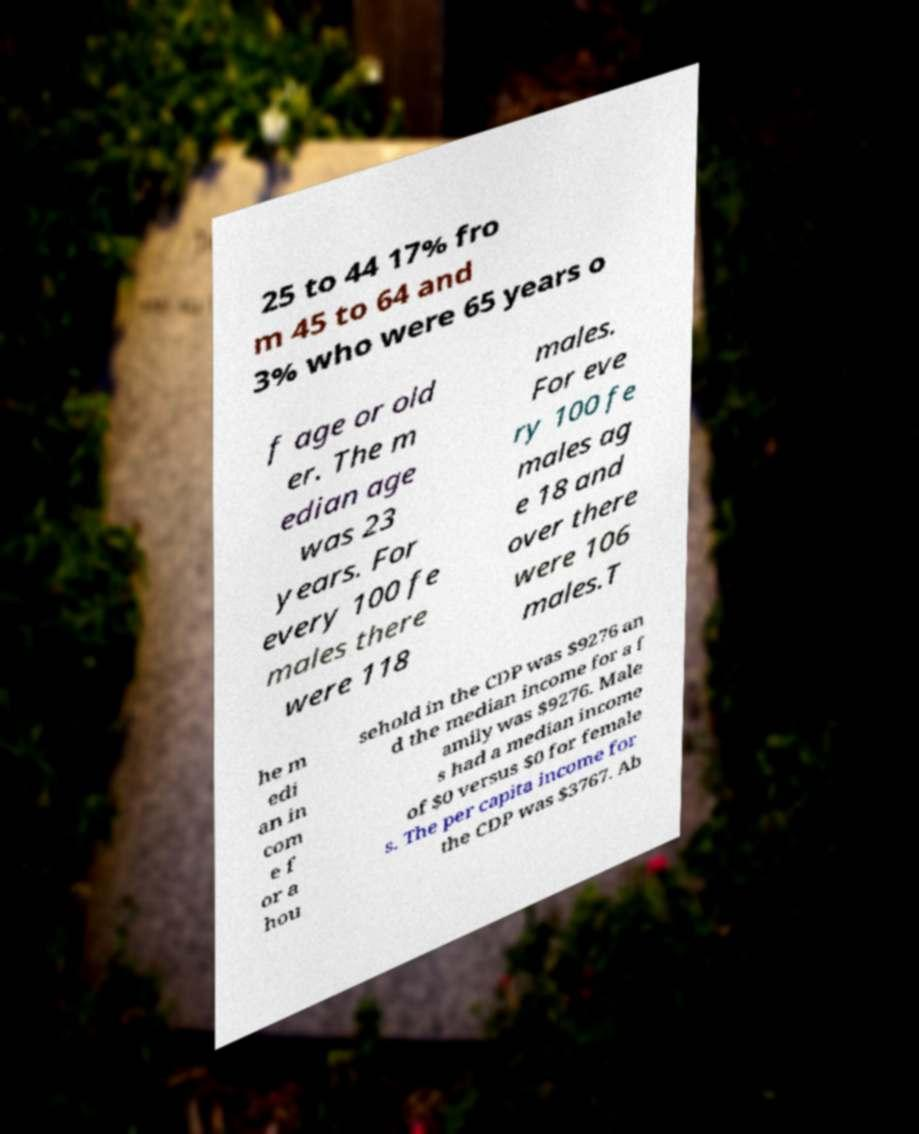What messages or text are displayed in this image? I need them in a readable, typed format. 25 to 44 17% fro m 45 to 64 and 3% who were 65 years o f age or old er. The m edian age was 23 years. For every 100 fe males there were 118 males. For eve ry 100 fe males ag e 18 and over there were 106 males.T he m edi an in com e f or a hou sehold in the CDP was $9276 an d the median income for a f amily was $9276. Male s had a median income of $0 versus $0 for female s. The per capita income for the CDP was $3767. Ab 